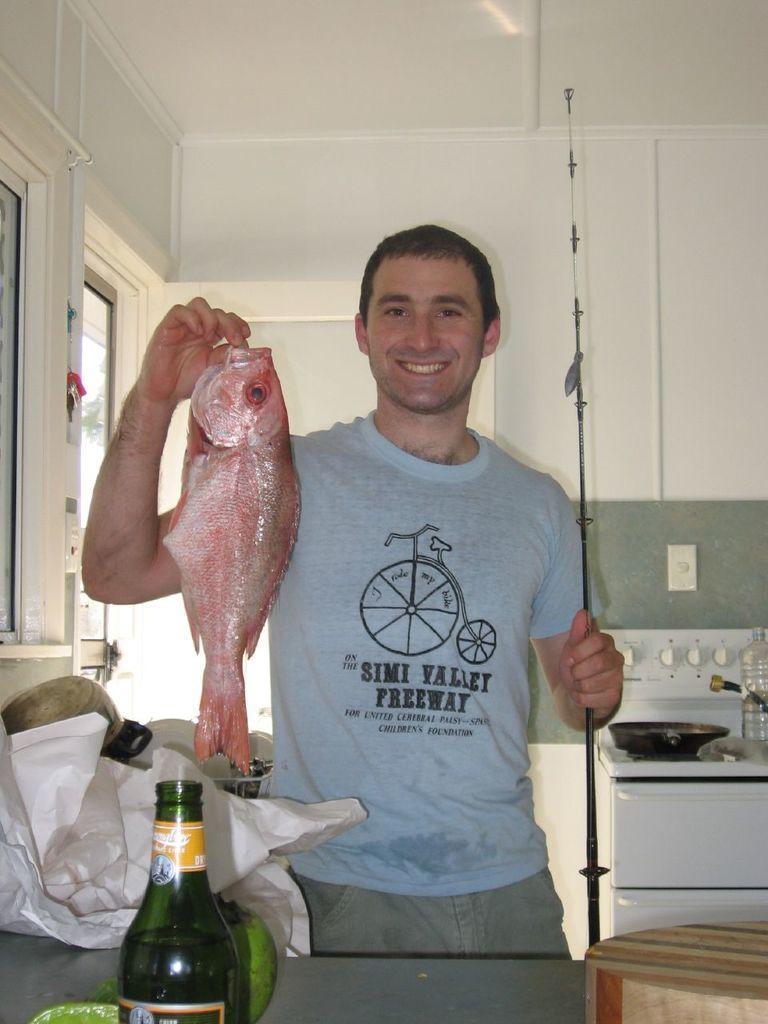Can you describe this image briefly? In this image i can see a person holding a fish and his smiling and his wearing a gray color t -shirt and in front of him there is a bottle kept on the table. front of him. on the right side i can see a bottle. and i can see a wall. and left side i can see a window. 